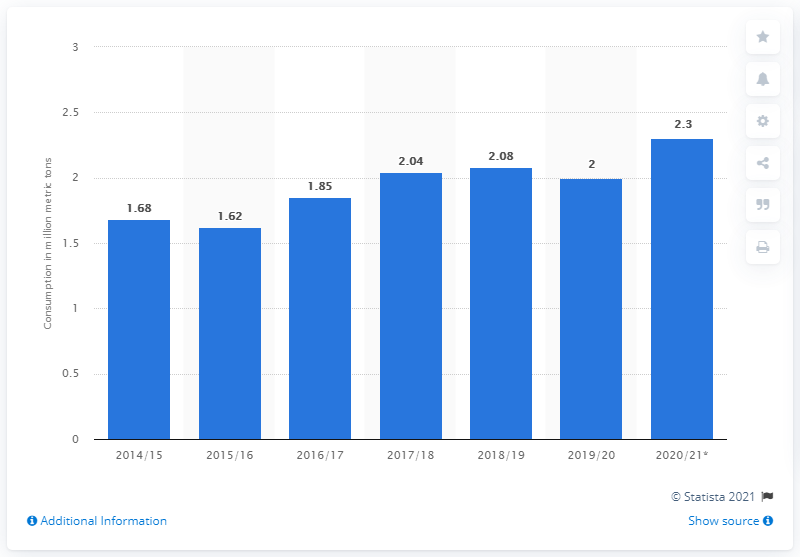List a handful of essential elements in this visual. In the marketing year 2019/2020, a total of 2,300 metric tons of oats were consumed in Canada. In the marketing year 2019/20, the consumption of oats in Canada was approximately 2 metric tons. 